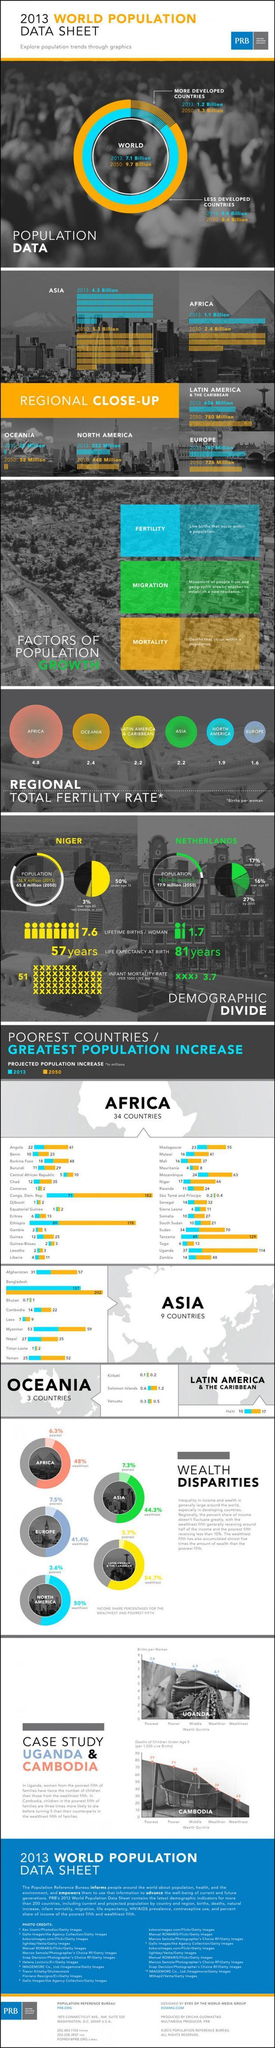which continent has highest fertility rate?
Answer the question with a short phrase. Africa what is the projected population increase of Bangladesh by 2050 in millions? 202 what is the projected population increase of Kirbati by 2050 in millions? 0.2 what is the projected population increase of Tanzania by 2050 in millions? 129 which continent has second highest fertility rate? oceania as per estimated data, which continent will be the most populous by 2050? Asia what is the projected population increase of Afghanistan by 2050 in millions? 57 what is the projected population increase of Sudan by 2050 in millions? 70 which African country has highest estimated population growth according to this data? Congo, Dem, rep. what is the projected population increase of Ethiopia by 2050 in millions? 178 which continent has lowest fertility rate? Europe what is the projected population of Asia by 2050 in billions? 5.3 which Asian country has lowest estimated population growth according to this data? Bhutan which Asian country has highest estimated population growth according to this data? Bangladesh what are the three main factors of population growth given in this infographic? fertility, migration, mortality 